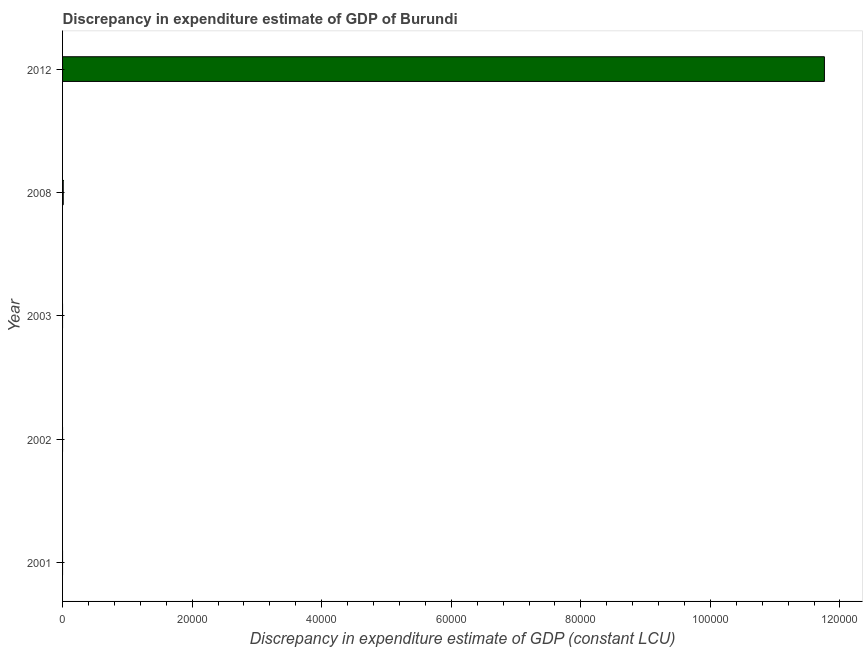Does the graph contain grids?
Your answer should be very brief. No. What is the title of the graph?
Provide a succinct answer. Discrepancy in expenditure estimate of GDP of Burundi. What is the label or title of the X-axis?
Ensure brevity in your answer.  Discrepancy in expenditure estimate of GDP (constant LCU). What is the discrepancy in expenditure estimate of gdp in 2001?
Give a very brief answer. 0. Across all years, what is the maximum discrepancy in expenditure estimate of gdp?
Your response must be concise. 1.18e+05. In which year was the discrepancy in expenditure estimate of gdp maximum?
Ensure brevity in your answer.  2012. What is the sum of the discrepancy in expenditure estimate of gdp?
Give a very brief answer. 1.18e+05. What is the difference between the discrepancy in expenditure estimate of gdp in 2008 and 2012?
Give a very brief answer. -1.18e+05. What is the average discrepancy in expenditure estimate of gdp per year?
Provide a short and direct response. 2.35e+04. Is the sum of the discrepancy in expenditure estimate of gdp in 2008 and 2012 greater than the maximum discrepancy in expenditure estimate of gdp across all years?
Offer a terse response. Yes. What is the difference between the highest and the lowest discrepancy in expenditure estimate of gdp?
Offer a terse response. 1.18e+05. How many years are there in the graph?
Offer a very short reply. 5. Are the values on the major ticks of X-axis written in scientific E-notation?
Give a very brief answer. No. What is the Discrepancy in expenditure estimate of GDP (constant LCU) in 2001?
Make the answer very short. 0. What is the Discrepancy in expenditure estimate of GDP (constant LCU) of 2002?
Your answer should be compact. 0. What is the Discrepancy in expenditure estimate of GDP (constant LCU) of 2008?
Keep it short and to the point. 100. What is the Discrepancy in expenditure estimate of GDP (constant LCU) of 2012?
Give a very brief answer. 1.18e+05. What is the difference between the Discrepancy in expenditure estimate of GDP (constant LCU) in 2008 and 2012?
Your answer should be very brief. -1.18e+05. What is the ratio of the Discrepancy in expenditure estimate of GDP (constant LCU) in 2008 to that in 2012?
Give a very brief answer. 0. 